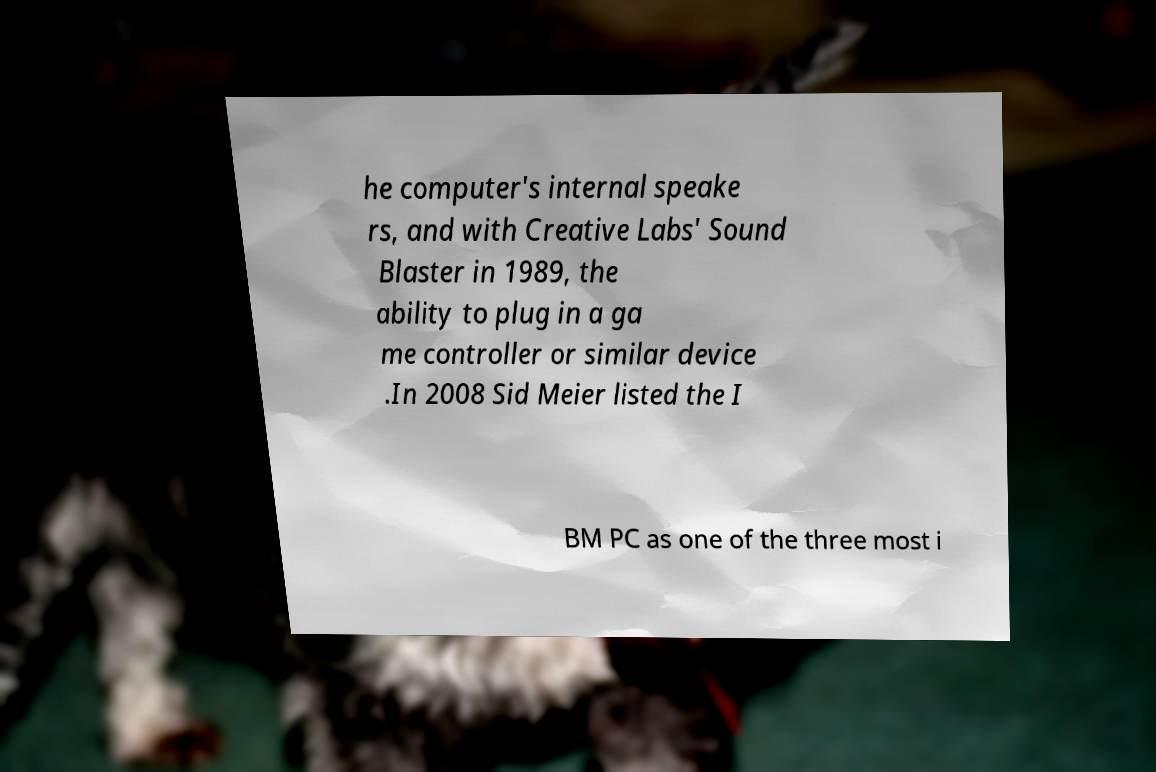For documentation purposes, I need the text within this image transcribed. Could you provide that? he computer's internal speake rs, and with Creative Labs' Sound Blaster in 1989, the ability to plug in a ga me controller or similar device .In 2008 Sid Meier listed the I BM PC as one of the three most i 